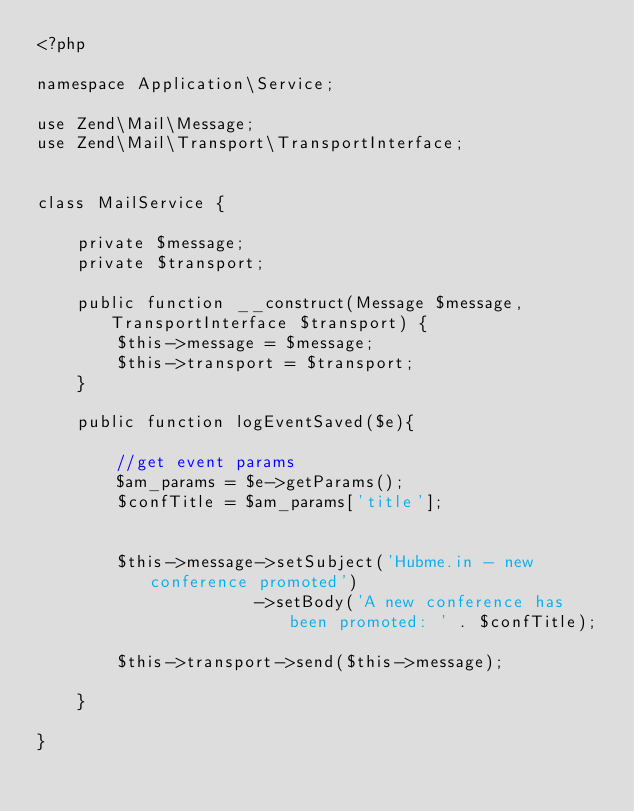<code> <loc_0><loc_0><loc_500><loc_500><_PHP_><?php

namespace Application\Service;

use Zend\Mail\Message;
use Zend\Mail\Transport\TransportInterface;


class MailService {

    private $message;
    private $transport;
    
    public function __construct(Message $message, TransportInterface $transport) {
        $this->message = $message;
        $this->transport = $transport;
    }

    public function logEventSaved($e){
        
        //get event params
        $am_params = $e->getParams();
        $confTitle = $am_params['title'];
        
        
        $this->message->setSubject('Hubme.in - new conference promoted')
                      ->setBody('A new conference has been promoted: ' . $confTitle);
         
        $this->transport->send($this->message);
        
    }

}
</code> 